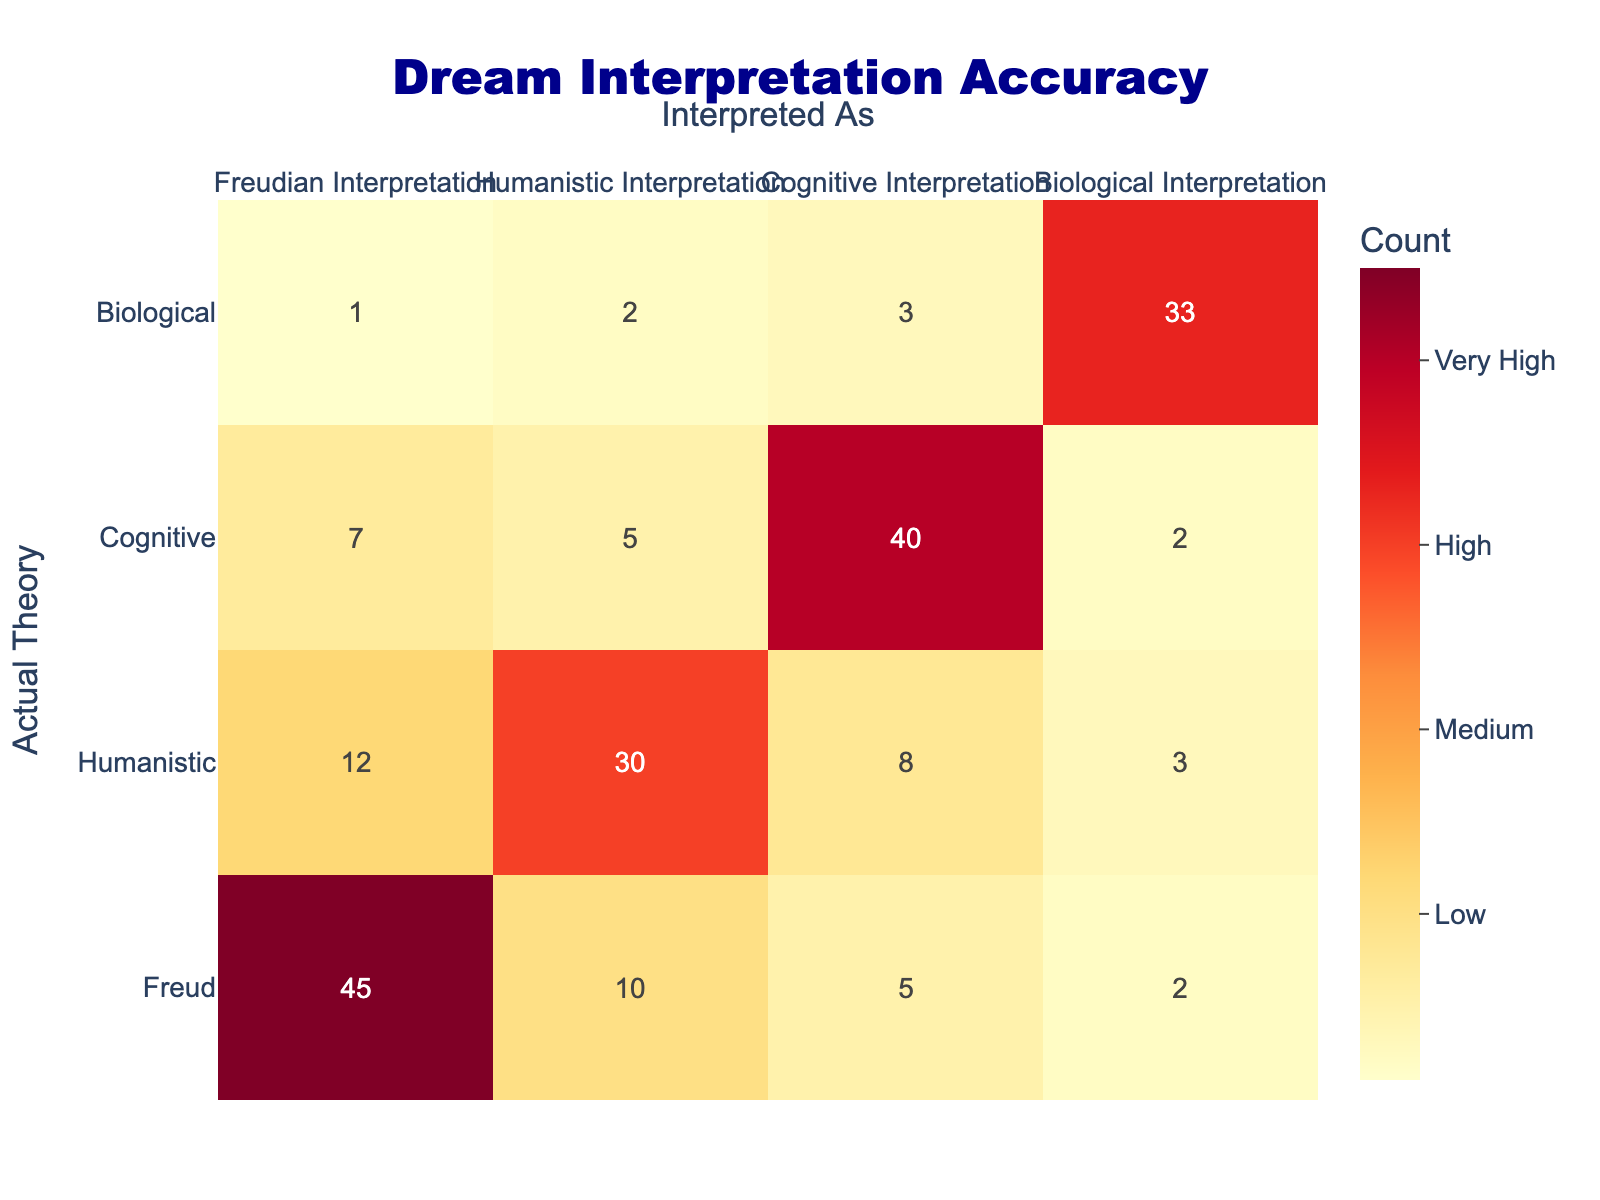What is the count of interpretations where the Freudian theory was correctly identified? Looking at the table, we see that for Freudian Interpretation (Freud), the count is 45.
Answer: 45 How many total interpretations were assigned the Humanistic Interpretation label? Summing the values in the Humanistic column gives us 12 (Freud) + 30 (Humanistic) + 8 (Cognitive) + 3 (Biological) = 53.
Answer: 53 Is the count of Cognitive Interpretation labels greater than the count of Biological Interpretation labels? The counts are 5 (Cognitive) and 3 (Biological) respectively. Since 5 is greater than 3, the statement is true.
Answer: Yes What is the total number of interpretations that were interpreted as Freudian? To find the total, sum all values in the Freudian Interpretation column: 45 (Freud) + 12 (Humanistic) + 7 (Cognitive) + 1 (Biological) = 65.
Answer: 65 What is the average count of interpretations for the Biological theory? To calculate the average, sum the counts in the Biological column: 2 (Freud) + 3 (Cognitive) + 33 (Biological) = 38. Then divide by the number of theory rows, which is 4: 38 / 4 = 9.5.
Answer: 9.5 Which interpretation had the highest count for the Biological theory? Looking at the counts, the highest is 33, which corresponds to the Biological theory itself.
Answer: 33 Is the total count for Freudian interpretation greater than the total count for Cognitive interpretation? The total for Freudian is 45 + 12 + 7 + 1 = 65, while for Cognitive it is 5 + 8 + 40 + 3 = 56. Since 65 is greater than 56, the statement is true.
Answer: Yes What is the difference in count between the Humanistic and Freudian interpretations categorized under Biological? In the Biological category, the counts are 2 (Humanistic) and 33 (Freudian). The difference is calculated as 33 - 2 = 31.
Answer: 31 What percentage of interpretations were accurately categorized as Cognitive? The accurate count for Cognitive is 40 (Cognitive) out of a total of (45 + 53 + 56 + 38) = 192. The percentage is (40 / 192) * 100 = 20.83%.
Answer: 20.83% 